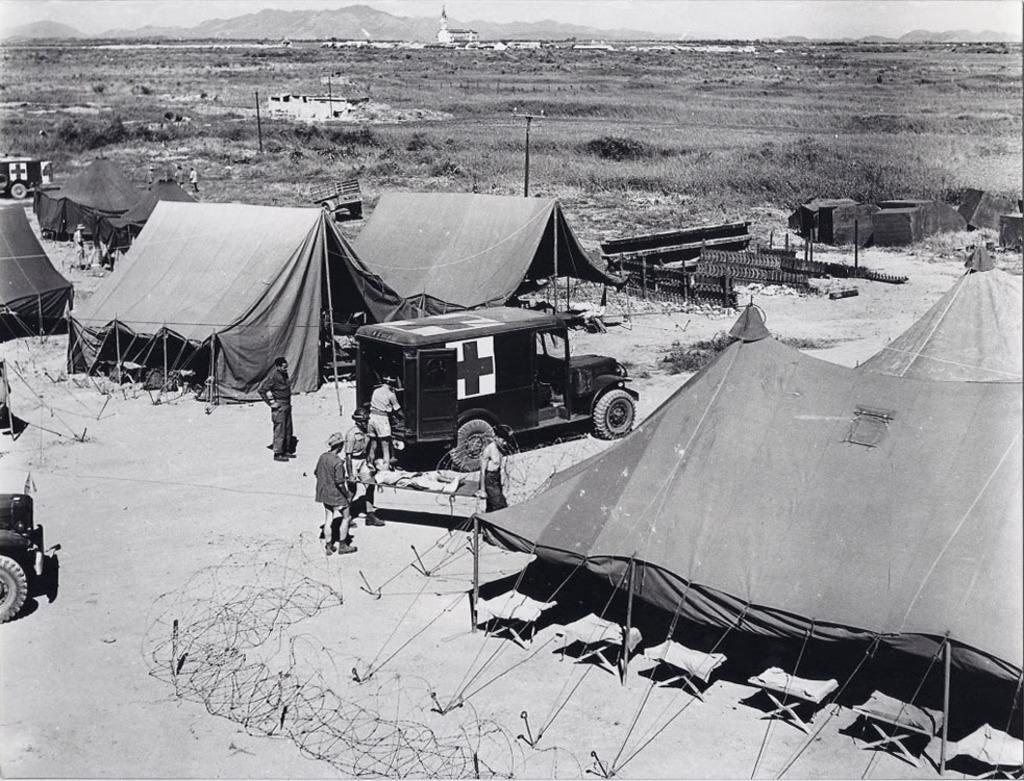Please provide a concise description of this image. In this image I can see few tents,poles,vehicles and few objects on the ground. Back I can see mountains,building,grass,few people. The image is in black and white color. 